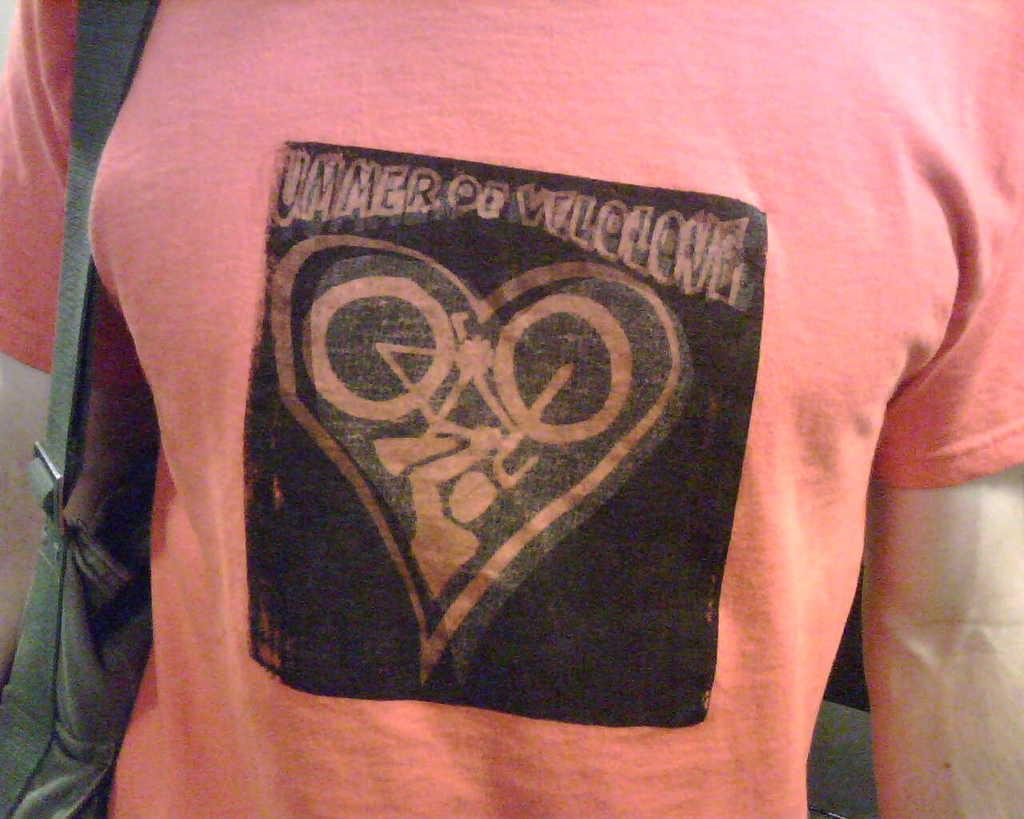What is present in the image? There is a person in the image. Can you describe the person's clothing? The person is wearing a t-shirt. What can be seen on the t-shirt? The t-shirt has an image and text on it. Who else is present in the image? There is a person holding a bag in the image. What type of jam is the person eating in the image? There is no jam present in the image; the person is wearing a t-shirt with an image and text on it. 